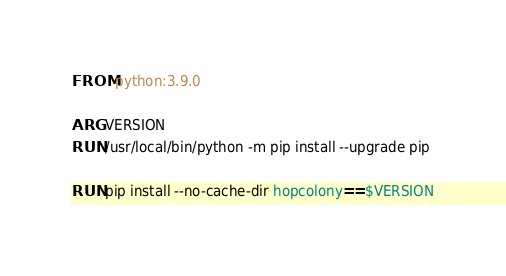Convert code to text. <code><loc_0><loc_0><loc_500><loc_500><_Dockerfile_>FROM python:3.9.0

ARG VERSION
RUN /usr/local/bin/python -m pip install --upgrade pip

RUN pip install --no-cache-dir hopcolony==$VERSION</code> 